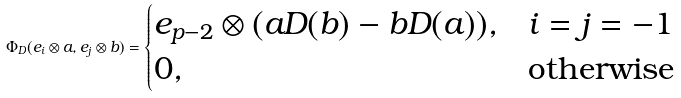Convert formula to latex. <formula><loc_0><loc_0><loc_500><loc_500>\Phi _ { D } ( e _ { i } \otimes a , e _ { j } \otimes b ) = \begin{cases} e _ { p - 2 } \otimes ( a D ( b ) - b D ( a ) ) , & i = j = - 1 \\ 0 , & \text {otherwise} \end{cases}</formula> 